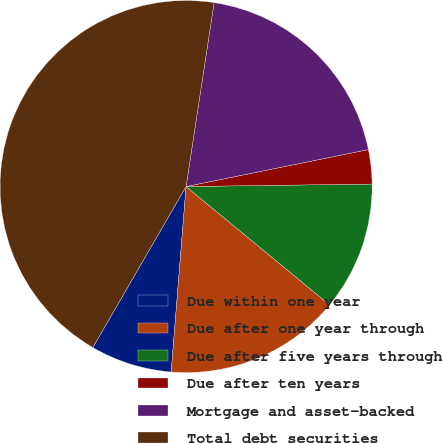Convert chart to OTSL. <chart><loc_0><loc_0><loc_500><loc_500><pie_chart><fcel>Due within one year<fcel>Due after one year through<fcel>Due after five years through<fcel>Due after ten years<fcel>Mortgage and asset-backed<fcel>Total debt securities<nl><fcel>7.08%<fcel>15.3%<fcel>11.19%<fcel>2.97%<fcel>19.41%<fcel>44.05%<nl></chart> 